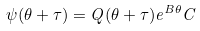<formula> <loc_0><loc_0><loc_500><loc_500>\psi ( \theta + \tau ) = Q ( \theta + \tau ) e ^ { B \theta } C \\</formula> 